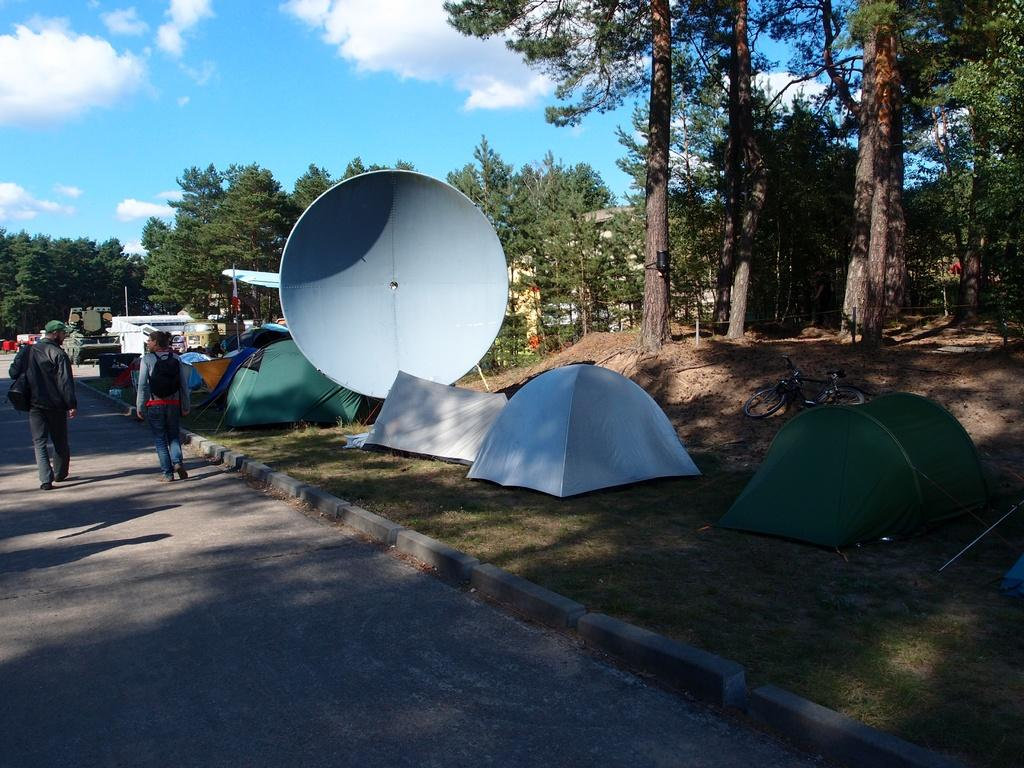How many people are in the image? There are two persons in the image. What can be seen on the road in the image? There are vehicles on the road in the image. What type of vegetation is visible in the image? There is grass visible in the image, as well as trees. What type of shelter is present in the image? There are tents in the image. What mode of transportation can be seen in the image? There is a bicycle in the image. What is visible in the background of the image? The sky is visible in the background of the image, with clouds present. How does the metal honey increase in the image? There is no metal, honey, or increase in the image; it features two persons, vehicles, grass, tents, a bicycle, trees, and a sky with clouds. 